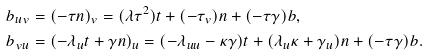Convert formula to latex. <formula><loc_0><loc_0><loc_500><loc_500>b _ { u v } & = ( - \tau n ) _ { v } = ( \lambda \tau ^ { 2 } ) t + ( - \tau _ { v } ) n + ( - \tau \gamma ) b , \\ b _ { v u } & = ( - \lambda _ { u } t + \gamma n ) _ { u } = ( - \lambda _ { u u } - \kappa \gamma ) t + ( \lambda _ { u } \kappa + \gamma _ { u } ) n + ( - \tau \gamma ) b .</formula> 